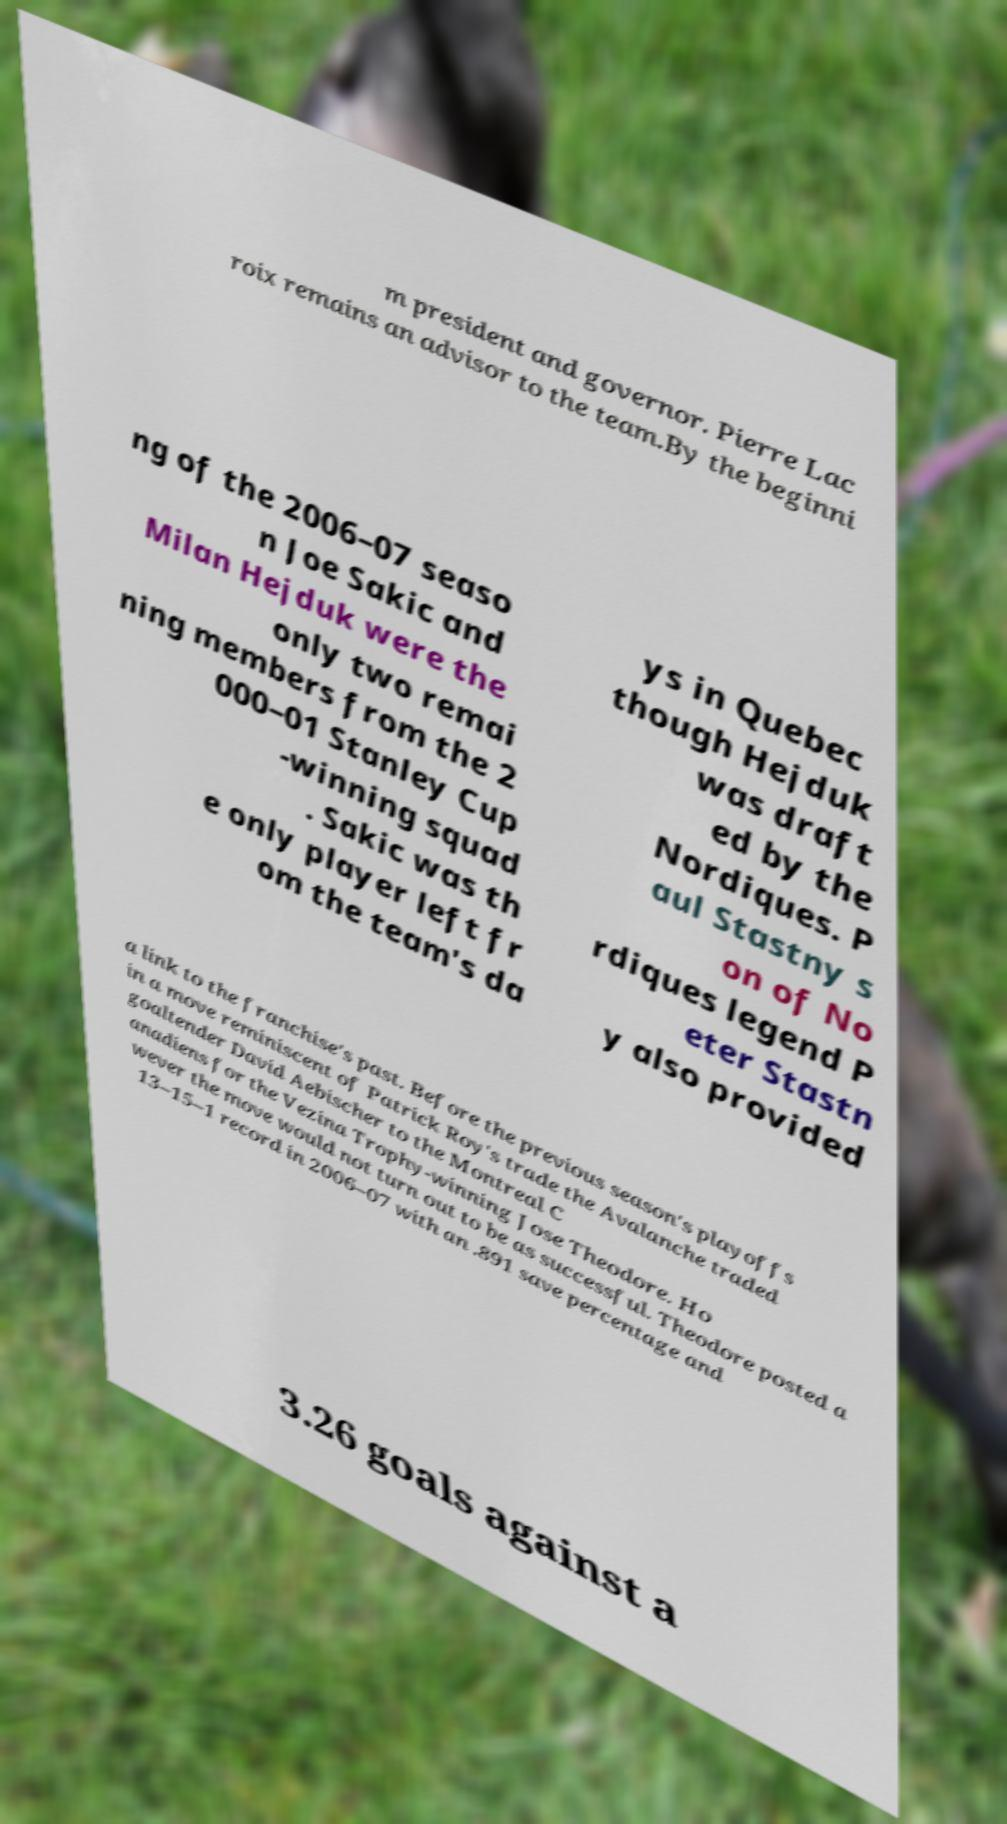Can you accurately transcribe the text from the provided image for me? m president and governor. Pierre Lac roix remains an advisor to the team.By the beginni ng of the 2006–07 seaso n Joe Sakic and Milan Hejduk were the only two remai ning members from the 2 000–01 Stanley Cup -winning squad . Sakic was th e only player left fr om the team's da ys in Quebec though Hejduk was draft ed by the Nordiques. P aul Stastny s on of No rdiques legend P eter Stastn y also provided a link to the franchise's past. Before the previous season's playoffs in a move reminiscent of Patrick Roy's trade the Avalanche traded goaltender David Aebischer to the Montreal C anadiens for the Vezina Trophy-winning Jose Theodore. Ho wever the move would not turn out to be as successful. Theodore posted a 13–15–1 record in 2006–07 with an .891 save percentage and 3.26 goals against a 